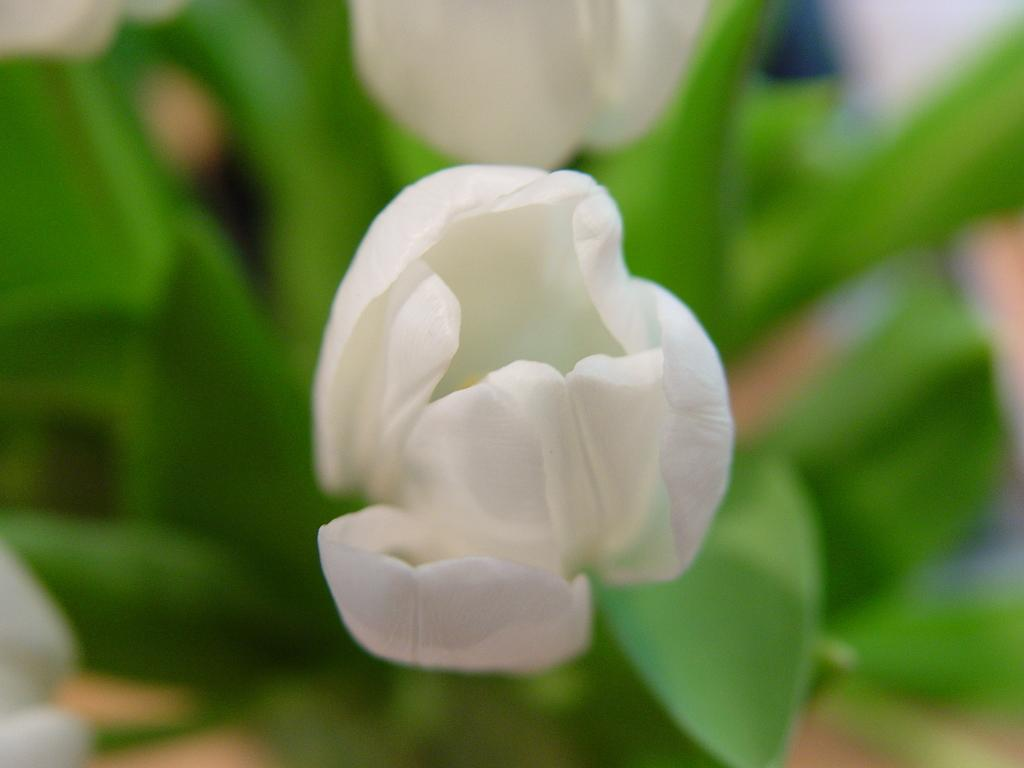What is the main subject of the image? There is a flower in the image. Can you describe the background of the image? The background of the image is blurred. What type of journey is the flower taking in the image? The flower is not taking a journey in the image; it is stationary. Is there a swing present in the image? No, there is no swing present in the image. 